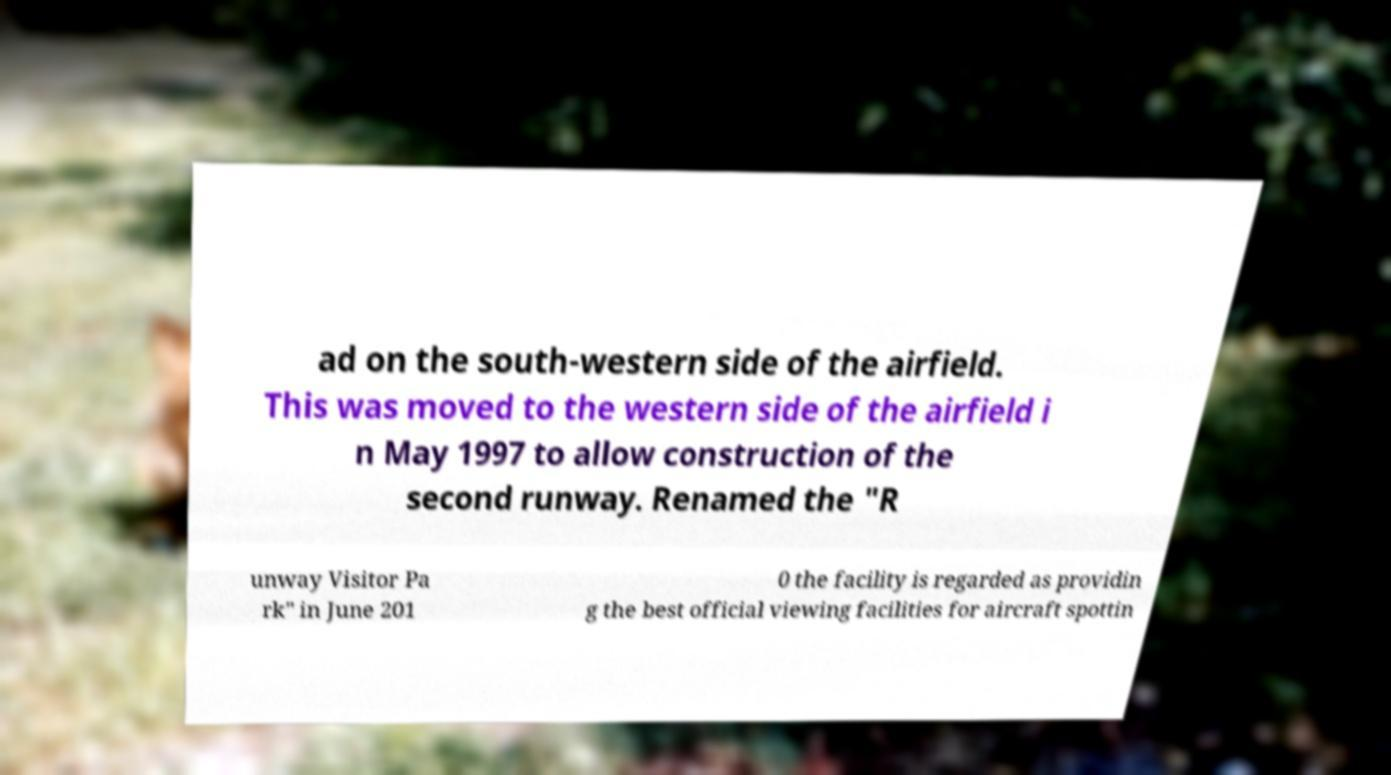Can you read and provide the text displayed in the image?This photo seems to have some interesting text. Can you extract and type it out for me? ad on the south-western side of the airfield. This was moved to the western side of the airfield i n May 1997 to allow construction of the second runway. Renamed the "R unway Visitor Pa rk" in June 201 0 the facility is regarded as providin g the best official viewing facilities for aircraft spottin 